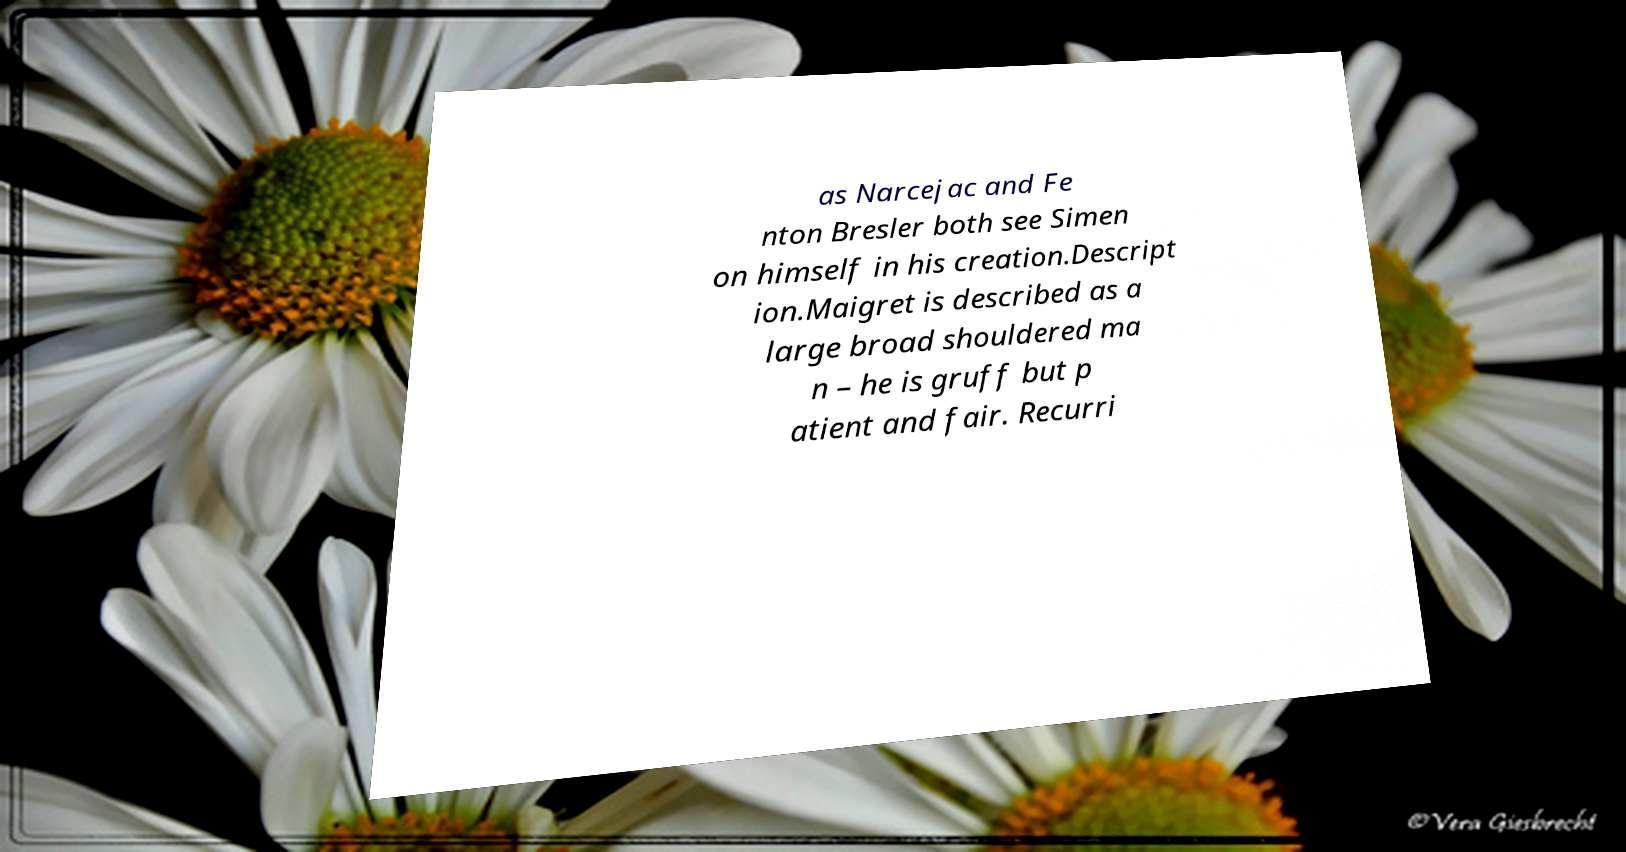There's text embedded in this image that I need extracted. Can you transcribe it verbatim? as Narcejac and Fe nton Bresler both see Simen on himself in his creation.Descript ion.Maigret is described as a large broad shouldered ma n – he is gruff but p atient and fair. Recurri 